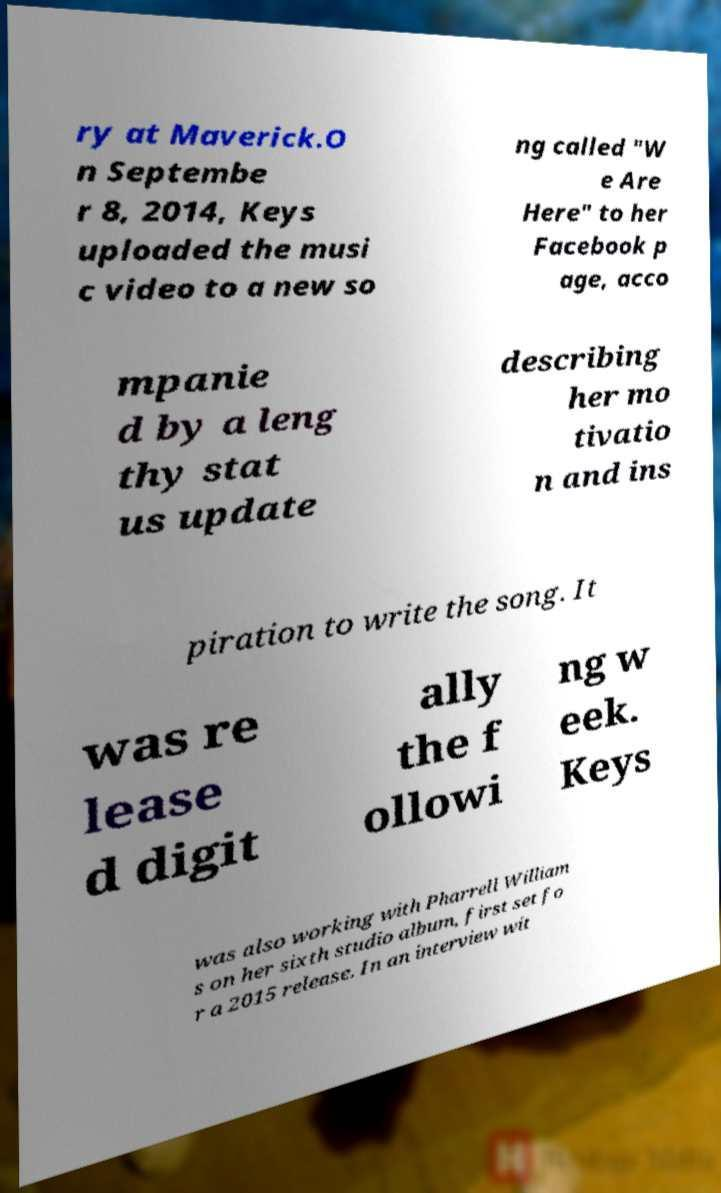There's text embedded in this image that I need extracted. Can you transcribe it verbatim? ry at Maverick.O n Septembe r 8, 2014, Keys uploaded the musi c video to a new so ng called "W e Are Here" to her Facebook p age, acco mpanie d by a leng thy stat us update describing her mo tivatio n and ins piration to write the song. It was re lease d digit ally the f ollowi ng w eek. Keys was also working with Pharrell William s on her sixth studio album, first set fo r a 2015 release. In an interview wit 